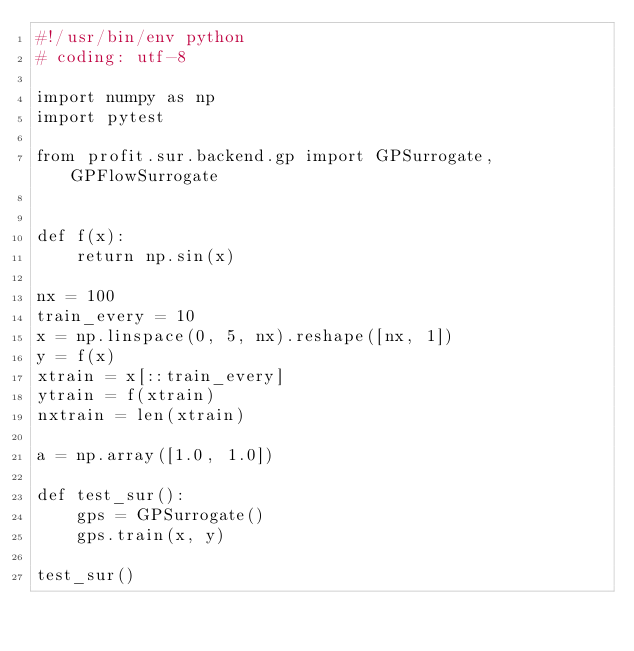<code> <loc_0><loc_0><loc_500><loc_500><_Python_>#!/usr/bin/env python
# coding: utf-8

import numpy as np
import pytest

from profit.sur.backend.gp import GPSurrogate, GPFlowSurrogate


def f(x):
    return np.sin(x)

nx = 100
train_every = 10
x = np.linspace(0, 5, nx).reshape([nx, 1])
y = f(x)
xtrain = x[::train_every]
ytrain = f(xtrain)
nxtrain = len(xtrain)

a = np.array([1.0, 1.0])

def test_sur():
    gps = GPSurrogate()
    gps.train(x, y)

test_sur()
</code> 